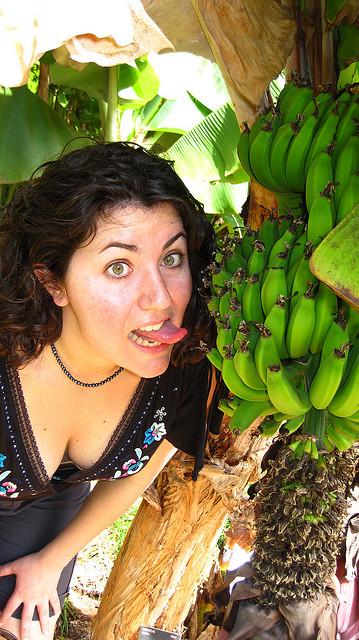Are the bananas ripe?
Write a very short answer. No. Is the woman wearing makeup?
Answer briefly. Yes. Why does the woman have her tongue out?
Answer briefly. Licking fruit. 